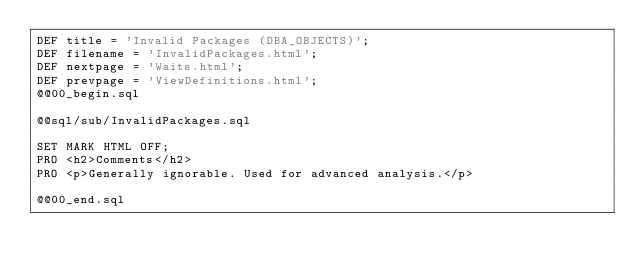Convert code to text. <code><loc_0><loc_0><loc_500><loc_500><_SQL_>DEF title = 'Invalid Packages (DBA_OBJECTS)';
DEF filename = 'InvalidPackages.html';
DEF nextpage = 'Waits.html';
DEF prevpage = 'ViewDefinitions.html';
@@00_begin.sql

@@sql/sub/InvalidPackages.sql

SET MARK HTML OFF;
PRO <h2>Comments</h2>
PRO <p>Generally ignorable. Used for advanced analysis.</p>

@@00_end.sql
</code> 